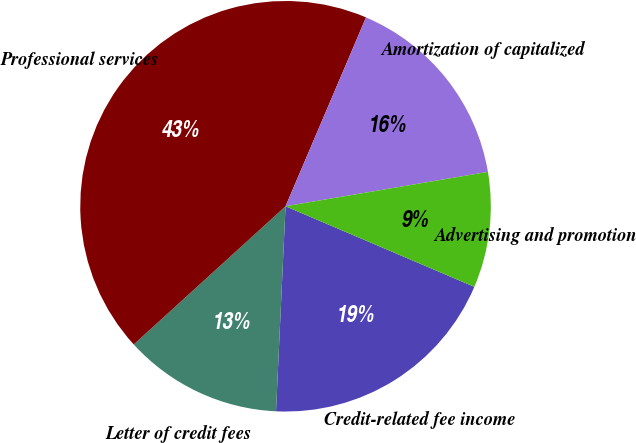Convert chart. <chart><loc_0><loc_0><loc_500><loc_500><pie_chart><fcel>Credit-related fee income<fcel>Letter of credit fees<fcel>Professional services<fcel>Amortization of capitalized<fcel>Advertising and promotion<nl><fcel>19.32%<fcel>12.51%<fcel>43.17%<fcel>15.91%<fcel>9.1%<nl></chart> 